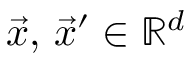<formula> <loc_0><loc_0><loc_500><loc_500>\vec { x } , \, \vec { x } ^ { \prime } \in \mathbb { R } ^ { d }</formula> 